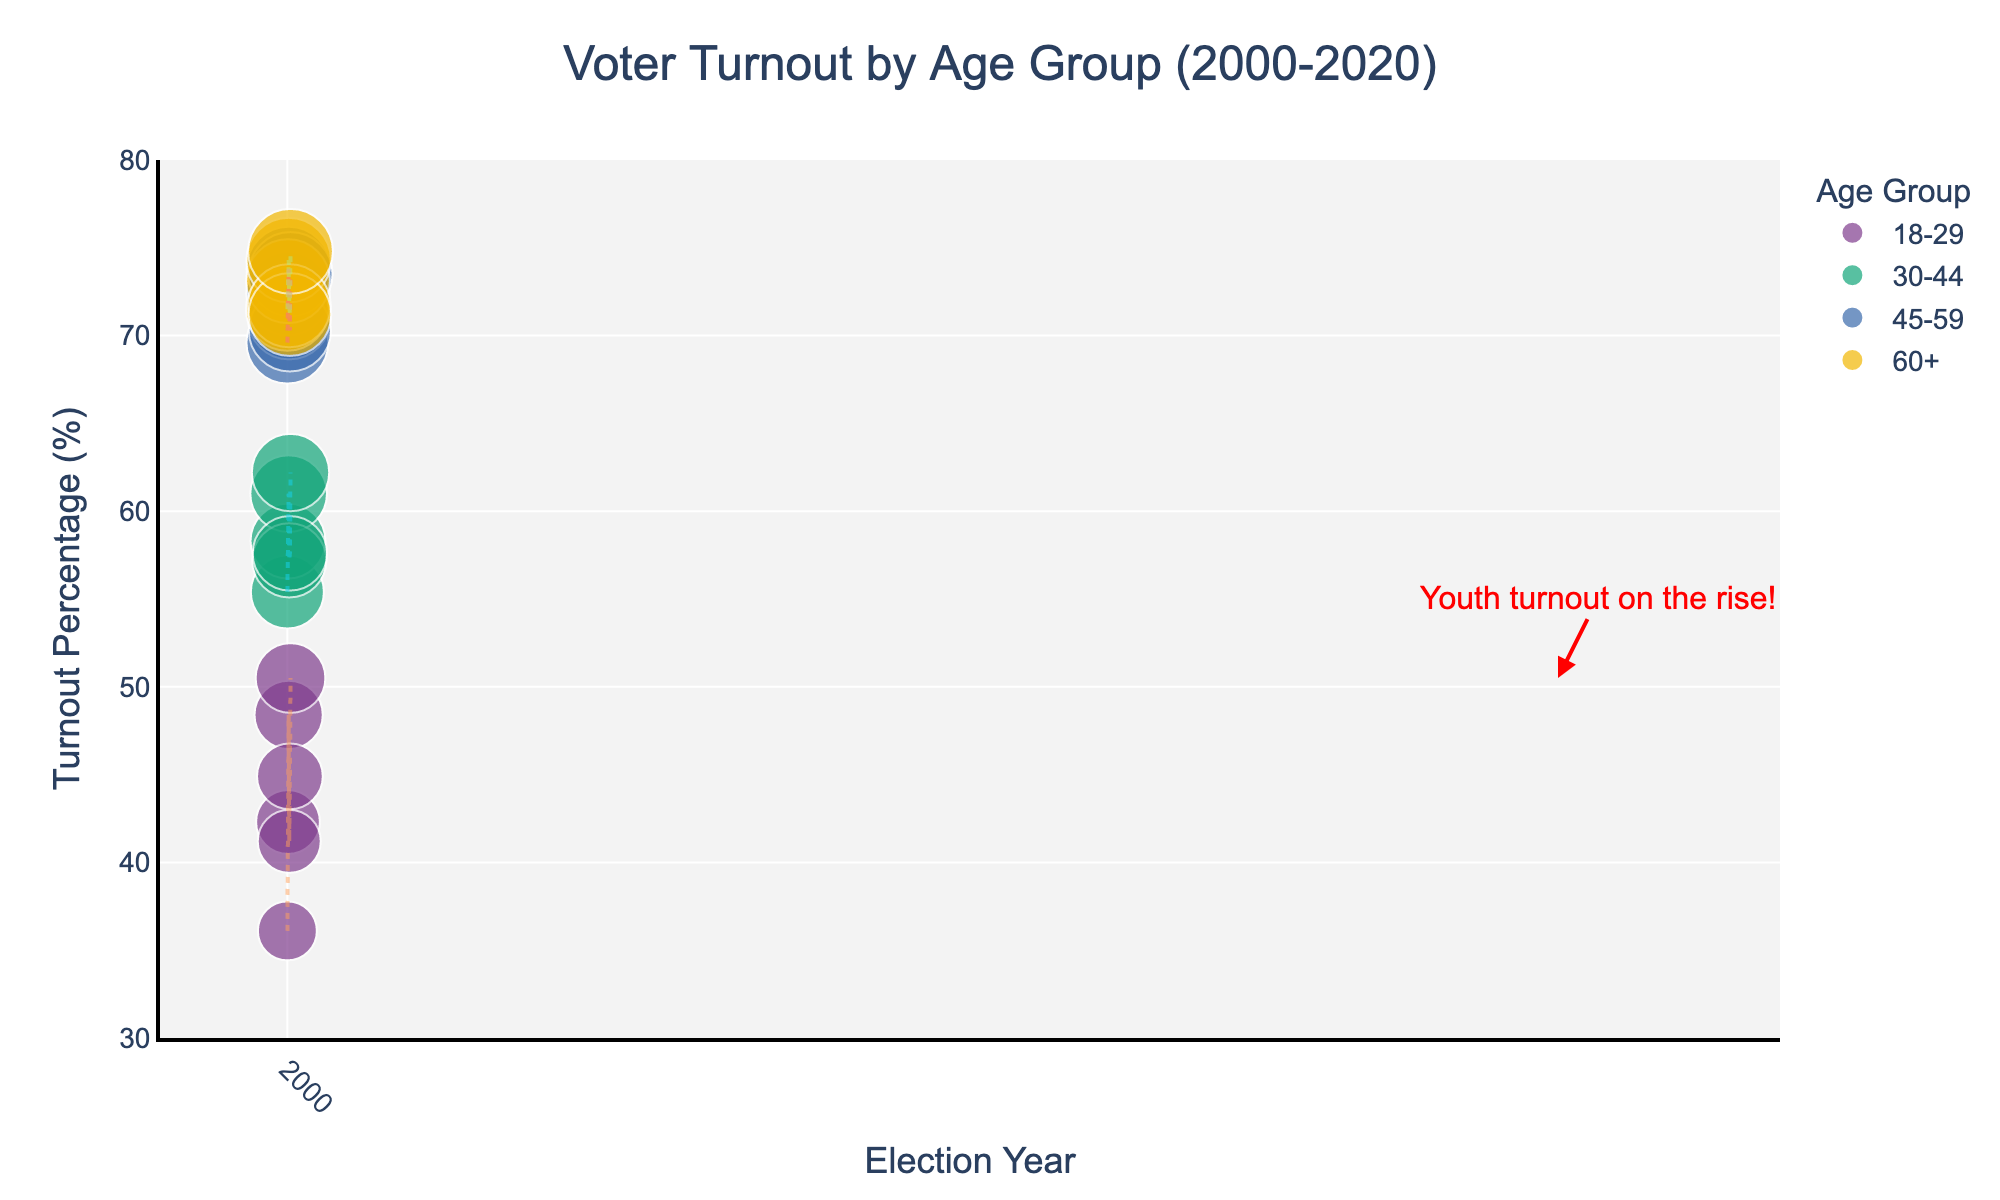what is the title of the plot? The title of the plot is displayed at the top of the figure in larger font size, reading "Voter Turnout by Age Group (2000-2020)"
Answer: Voter Turnout by Age Group (2000-2020) Which age group had the highest voter turnout in 2020? By observing the data points for the year 2020, the age group with the highest turnout is represented by the largest point on the plot. The '60+' age group had the highest voter turnout in 2020.
Answer: 60+ What is the voter turnout percentage for the '18-29' age group in 2008? Locate the '18-29' age group data point for the year 2008 and read the turnout percentage. The voter turnout for the '18-29' age group in 2008 is 48.4%.
Answer: 48.4% What is the trend in voter turnout for the '18-29' age group from 2000 to 2020? Follow the dotted line representing the '18-29' age group across the years from 2000 to 2020. The trend shows an overall increase in voter turnout from 36.1% in 2000 to 50.5% in 2020.
Answer: Increase Which age group shows the least variation in voter turnout percentages over the years 2000 to 2020? Analyze each age group's trend line. The '60+' age group shows very consistent high turnout percentages, ranging from 71.2% to 74.8%, indicating the least variation.
Answer: 60+ How does the voter turnout percentage of the '30-44' age group in 2016 compare to that in 2020? Compare the data points for the '30-44' age group in 2016 and 2020. The turnout in 2016 was 57.6%, while it increased to 62.2% in 2020.
Answer: Increased by 4.6% What is the average voter turnout percentage for the '45-59' age group across all years represented? Sum the voter turnout percentages for the '45-59' age group (69.6, 72.4, 73.8, 71.0, 70.3, 73.5) and divide by the number of data points (6 years). The average is (69.6 + 72.4 + 73.8 + 71.0 + 70.3 + 73.5) / 6 = 71.8%.
Answer: 71.8% Which age group had the highest increase in voter turnout between 2016 and 2020? Calculate the difference in turnout percentages for each age group between 2016 and 2020. The '18-29' age group had the highest increase, from 44.9% in 2016 to 50.5% in 2020.
Answer: 18-29 